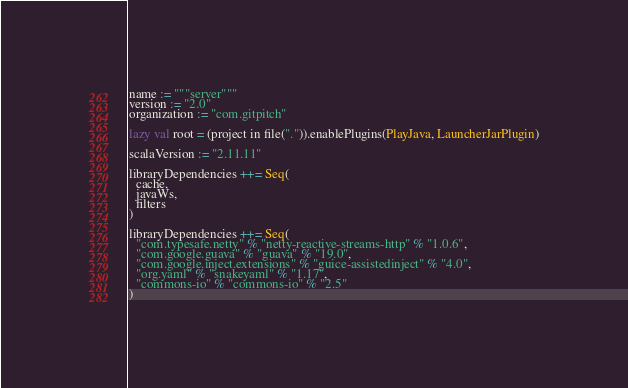<code> <loc_0><loc_0><loc_500><loc_500><_Scala_>name := """server"""
version := "2.0"
organization := "com.gitpitch"

lazy val root = (project in file(".")).enablePlugins(PlayJava, LauncherJarPlugin)

scalaVersion := "2.11.11"

libraryDependencies ++= Seq(
  cache,
  javaWs,
  filters
)

libraryDependencies ++= Seq(
  "com.typesafe.netty" % "netty-reactive-streams-http" % "1.0.6",
  "com.google.guava" % "guava" % "19.0",
  "com.google.inject.extensions" % "guice-assistedinject" % "4.0",
  "org.yaml" % "snakeyaml" % "1.17",
  "commons-io" % "commons-io" % "2.5"
)
</code> 